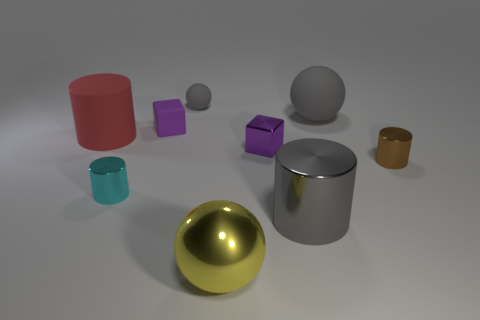Subtract 1 cylinders. How many cylinders are left? 3 Add 1 tiny objects. How many objects exist? 10 Subtract all yellow cylinders. Subtract all green blocks. How many cylinders are left? 4 Subtract all cylinders. How many objects are left? 5 Add 3 small gray objects. How many small gray objects exist? 4 Subtract 1 gray cylinders. How many objects are left? 8 Subtract all shiny spheres. Subtract all purple cubes. How many objects are left? 6 Add 2 large red cylinders. How many large red cylinders are left? 3 